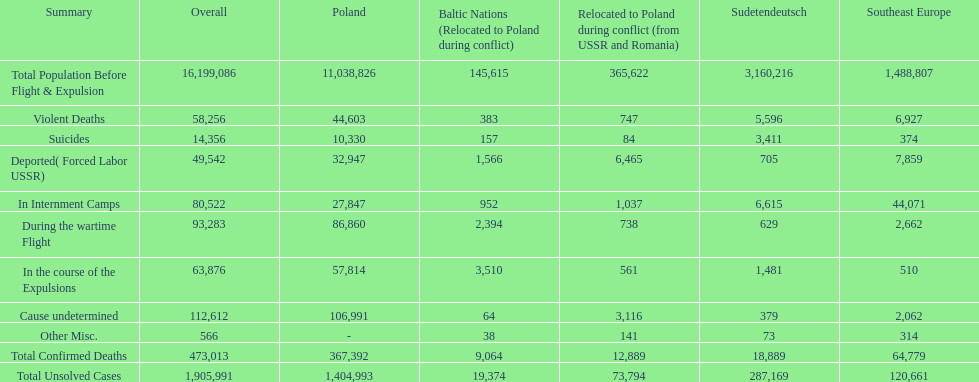Which country had the larger death tole? Poland. 